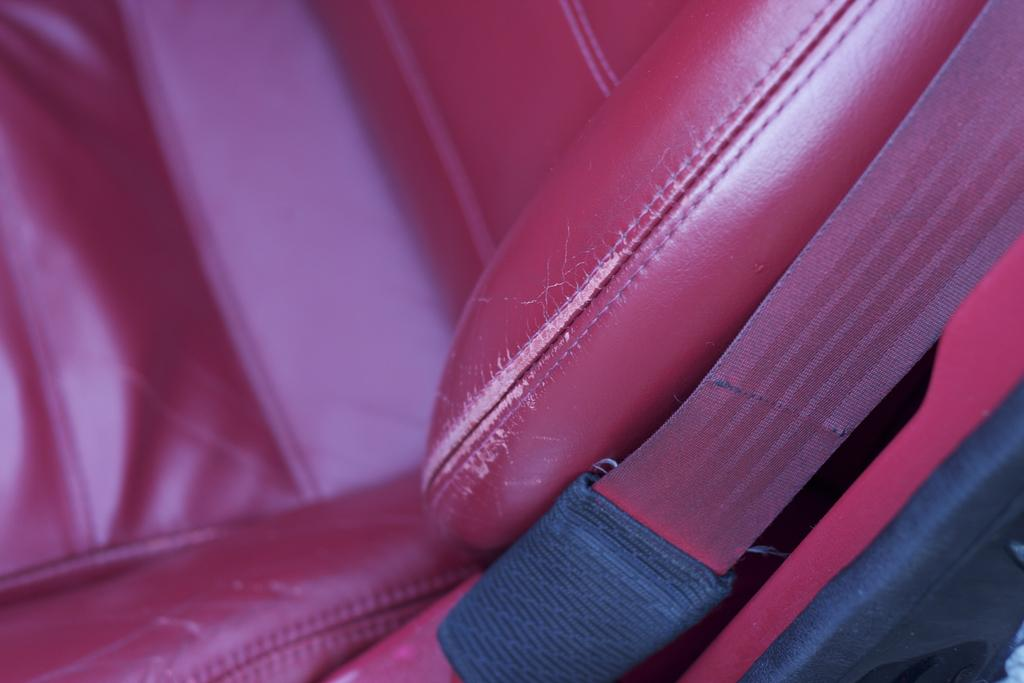What is present in the image that people can sit on? There is a seat in the image. What safety feature is visible in the image? There is a seat belt in the image. What type of thrill can be experienced by the branch in the image? There is no branch present in the image, so it cannot be determined if any thrill can be experienced. 